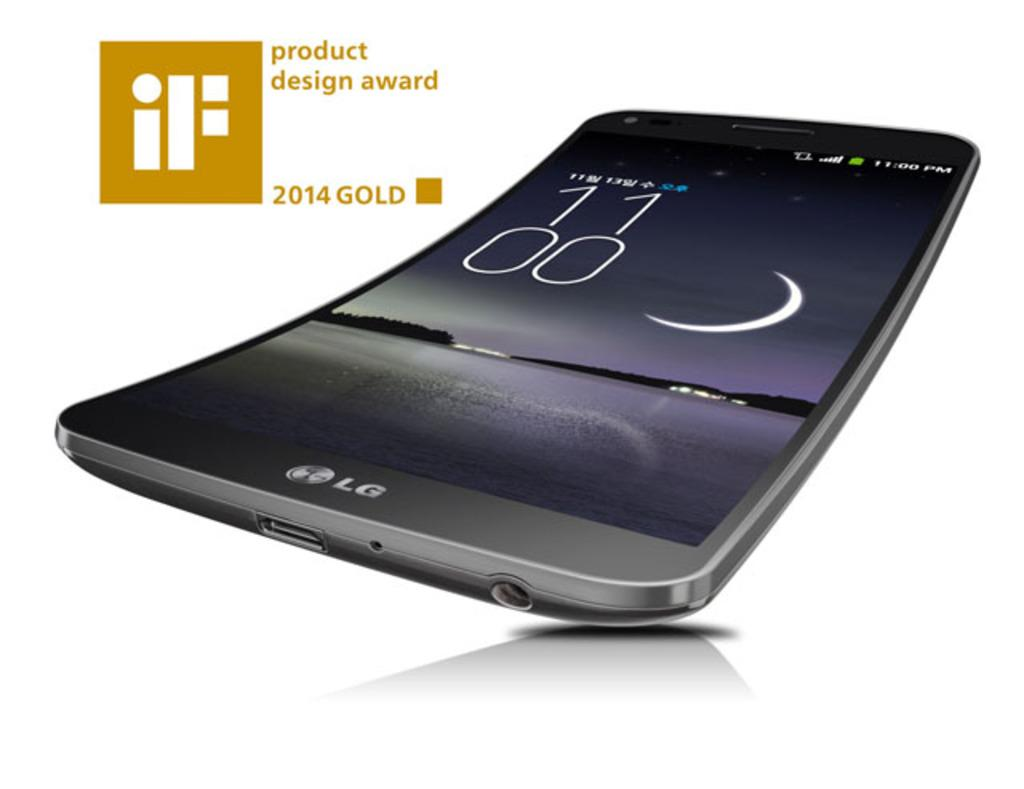<image>
Summarize the visual content of the image. a bending cell phone from LG that won the iF product design AWARD 2014 